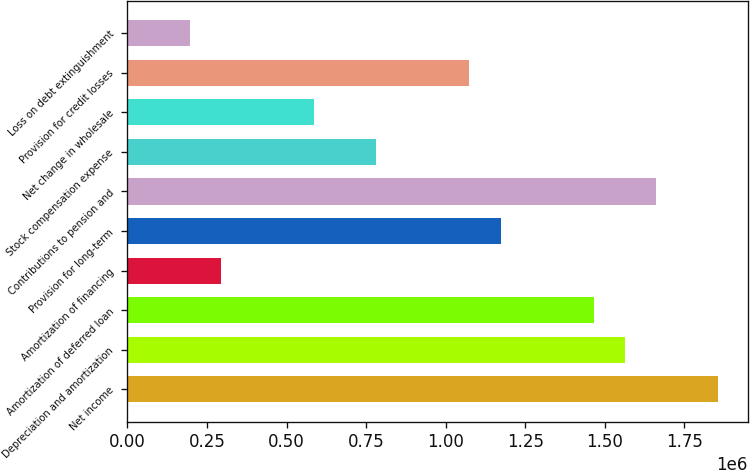Convert chart to OTSL. <chart><loc_0><loc_0><loc_500><loc_500><bar_chart><fcel>Net income<fcel>Depreciation and amortization<fcel>Amortization of deferred loan<fcel>Amortization of financing<fcel>Provision for long-term<fcel>Contributions to pension and<fcel>Stock compensation expense<fcel>Net change in wholesale<fcel>Provision for credit losses<fcel>Loss on debt extinguishment<nl><fcel>1.85617e+06<fcel>1.56314e+06<fcel>1.46547e+06<fcel>293370<fcel>1.17244e+06<fcel>1.66082e+06<fcel>781744<fcel>586394<fcel>1.07477e+06<fcel>195695<nl></chart> 